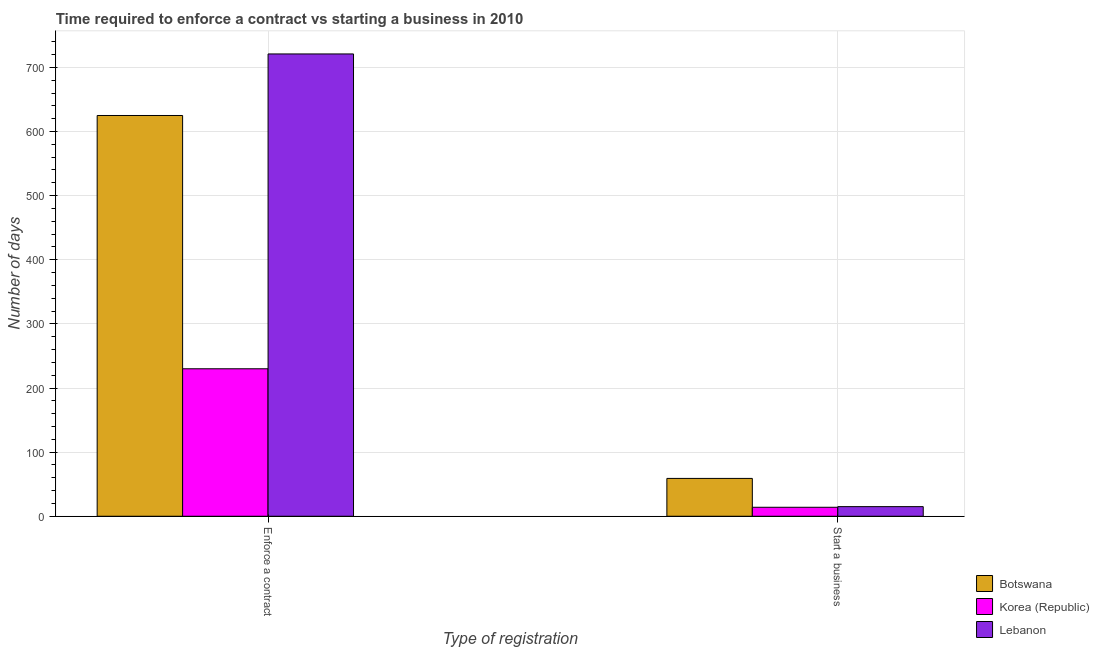How many different coloured bars are there?
Keep it short and to the point. 3. How many groups of bars are there?
Your response must be concise. 2. Are the number of bars on each tick of the X-axis equal?
Your answer should be very brief. Yes. How many bars are there on the 2nd tick from the left?
Your answer should be very brief. 3. What is the label of the 2nd group of bars from the left?
Your answer should be very brief. Start a business. What is the number of days to start a business in Korea (Republic)?
Ensure brevity in your answer.  14. Across all countries, what is the maximum number of days to enforece a contract?
Keep it short and to the point. 721. Across all countries, what is the minimum number of days to enforece a contract?
Offer a very short reply. 230. In which country was the number of days to start a business maximum?
Keep it short and to the point. Botswana. What is the total number of days to start a business in the graph?
Ensure brevity in your answer.  88. What is the difference between the number of days to enforece a contract in Botswana and that in Lebanon?
Ensure brevity in your answer.  -96. What is the difference between the number of days to start a business in Korea (Republic) and the number of days to enforece a contract in Lebanon?
Your answer should be very brief. -707. What is the average number of days to enforece a contract per country?
Offer a terse response. 525.33. What is the difference between the number of days to start a business and number of days to enforece a contract in Botswana?
Keep it short and to the point. -566. In how many countries, is the number of days to enforece a contract greater than 540 days?
Give a very brief answer. 2. What is the ratio of the number of days to start a business in Lebanon to that in Korea (Republic)?
Give a very brief answer. 1.07. In how many countries, is the number of days to enforece a contract greater than the average number of days to enforece a contract taken over all countries?
Your response must be concise. 2. What does the 3rd bar from the left in Enforce a contract represents?
Your response must be concise. Lebanon. What does the 1st bar from the right in Start a business represents?
Keep it short and to the point. Lebanon. How many bars are there?
Provide a succinct answer. 6. What is the difference between two consecutive major ticks on the Y-axis?
Ensure brevity in your answer.  100. Are the values on the major ticks of Y-axis written in scientific E-notation?
Your answer should be very brief. No. Where does the legend appear in the graph?
Provide a short and direct response. Bottom right. How many legend labels are there?
Your response must be concise. 3. How are the legend labels stacked?
Keep it short and to the point. Vertical. What is the title of the graph?
Keep it short and to the point. Time required to enforce a contract vs starting a business in 2010. What is the label or title of the X-axis?
Your response must be concise. Type of registration. What is the label or title of the Y-axis?
Your answer should be very brief. Number of days. What is the Number of days of Botswana in Enforce a contract?
Keep it short and to the point. 625. What is the Number of days in Korea (Republic) in Enforce a contract?
Provide a short and direct response. 230. What is the Number of days of Lebanon in Enforce a contract?
Your answer should be very brief. 721. What is the Number of days in Lebanon in Start a business?
Keep it short and to the point. 15. Across all Type of registration, what is the maximum Number of days in Botswana?
Provide a short and direct response. 625. Across all Type of registration, what is the maximum Number of days in Korea (Republic)?
Your response must be concise. 230. Across all Type of registration, what is the maximum Number of days of Lebanon?
Your response must be concise. 721. What is the total Number of days in Botswana in the graph?
Provide a short and direct response. 684. What is the total Number of days in Korea (Republic) in the graph?
Your answer should be compact. 244. What is the total Number of days of Lebanon in the graph?
Your response must be concise. 736. What is the difference between the Number of days of Botswana in Enforce a contract and that in Start a business?
Ensure brevity in your answer.  566. What is the difference between the Number of days in Korea (Republic) in Enforce a contract and that in Start a business?
Provide a succinct answer. 216. What is the difference between the Number of days of Lebanon in Enforce a contract and that in Start a business?
Your response must be concise. 706. What is the difference between the Number of days of Botswana in Enforce a contract and the Number of days of Korea (Republic) in Start a business?
Offer a very short reply. 611. What is the difference between the Number of days in Botswana in Enforce a contract and the Number of days in Lebanon in Start a business?
Give a very brief answer. 610. What is the difference between the Number of days of Korea (Republic) in Enforce a contract and the Number of days of Lebanon in Start a business?
Your answer should be very brief. 215. What is the average Number of days of Botswana per Type of registration?
Provide a short and direct response. 342. What is the average Number of days in Korea (Republic) per Type of registration?
Your answer should be compact. 122. What is the average Number of days in Lebanon per Type of registration?
Your response must be concise. 368. What is the difference between the Number of days in Botswana and Number of days in Korea (Republic) in Enforce a contract?
Keep it short and to the point. 395. What is the difference between the Number of days in Botswana and Number of days in Lebanon in Enforce a contract?
Your answer should be very brief. -96. What is the difference between the Number of days of Korea (Republic) and Number of days of Lebanon in Enforce a contract?
Provide a short and direct response. -491. What is the difference between the Number of days of Botswana and Number of days of Lebanon in Start a business?
Ensure brevity in your answer.  44. What is the ratio of the Number of days in Botswana in Enforce a contract to that in Start a business?
Offer a very short reply. 10.59. What is the ratio of the Number of days in Korea (Republic) in Enforce a contract to that in Start a business?
Give a very brief answer. 16.43. What is the ratio of the Number of days in Lebanon in Enforce a contract to that in Start a business?
Your answer should be very brief. 48.07. What is the difference between the highest and the second highest Number of days in Botswana?
Your response must be concise. 566. What is the difference between the highest and the second highest Number of days in Korea (Republic)?
Keep it short and to the point. 216. What is the difference between the highest and the second highest Number of days of Lebanon?
Your response must be concise. 706. What is the difference between the highest and the lowest Number of days in Botswana?
Your response must be concise. 566. What is the difference between the highest and the lowest Number of days in Korea (Republic)?
Provide a succinct answer. 216. What is the difference between the highest and the lowest Number of days in Lebanon?
Make the answer very short. 706. 